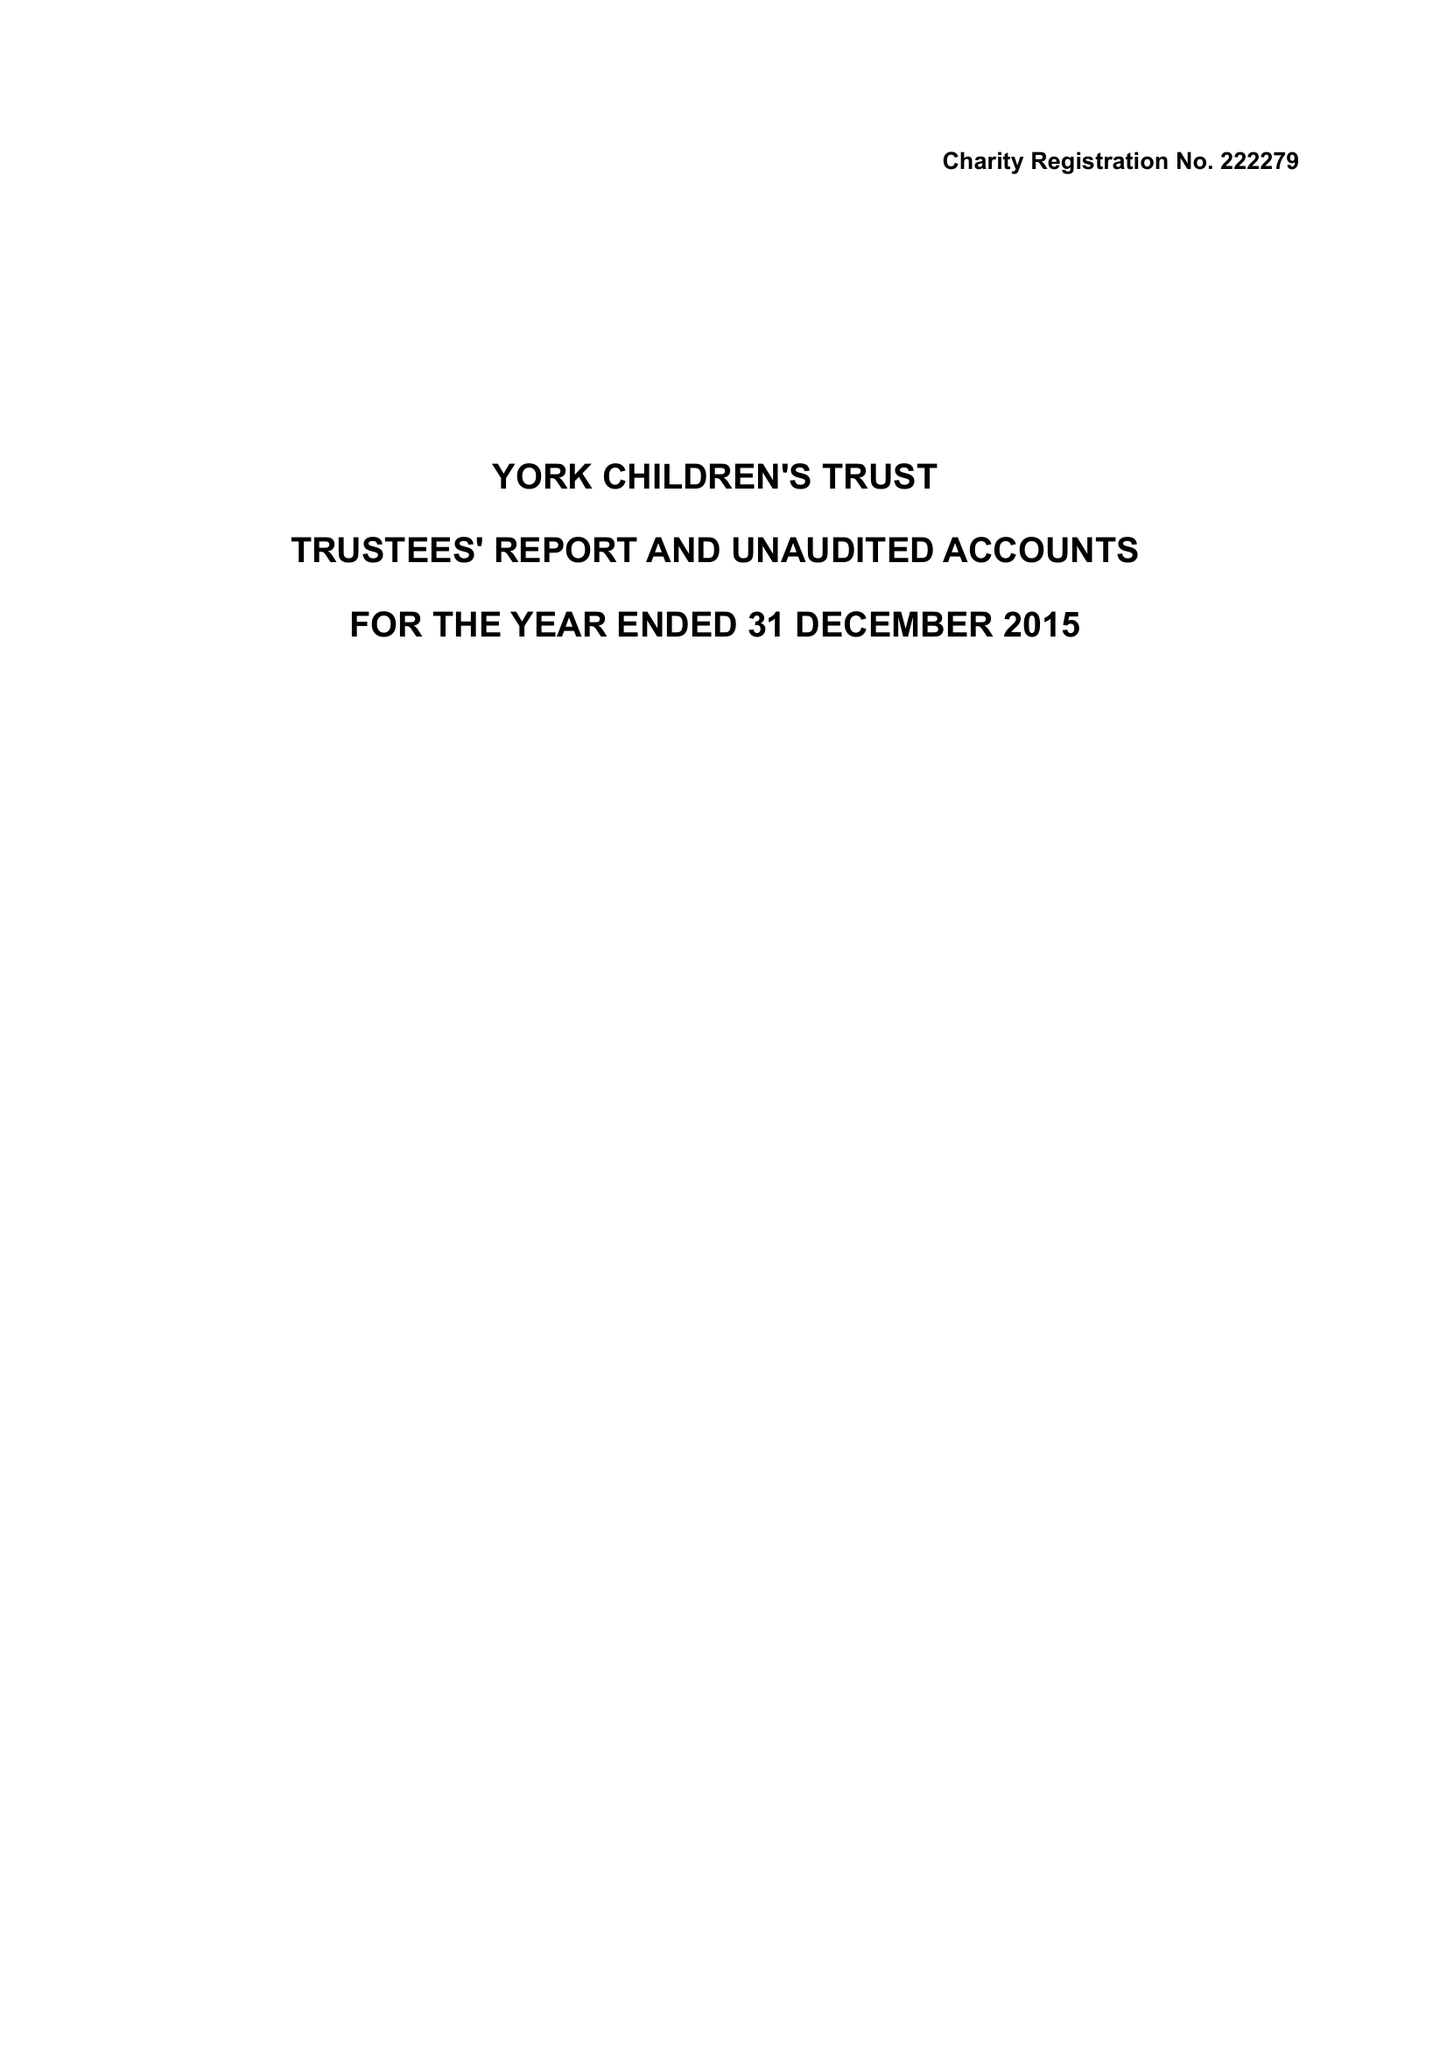What is the value for the spending_annually_in_british_pounds?
Answer the question using a single word or phrase. 97184.00 